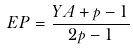<formula> <loc_0><loc_0><loc_500><loc_500>E P = \frac { Y A + p - 1 } { 2 p - 1 }</formula> 